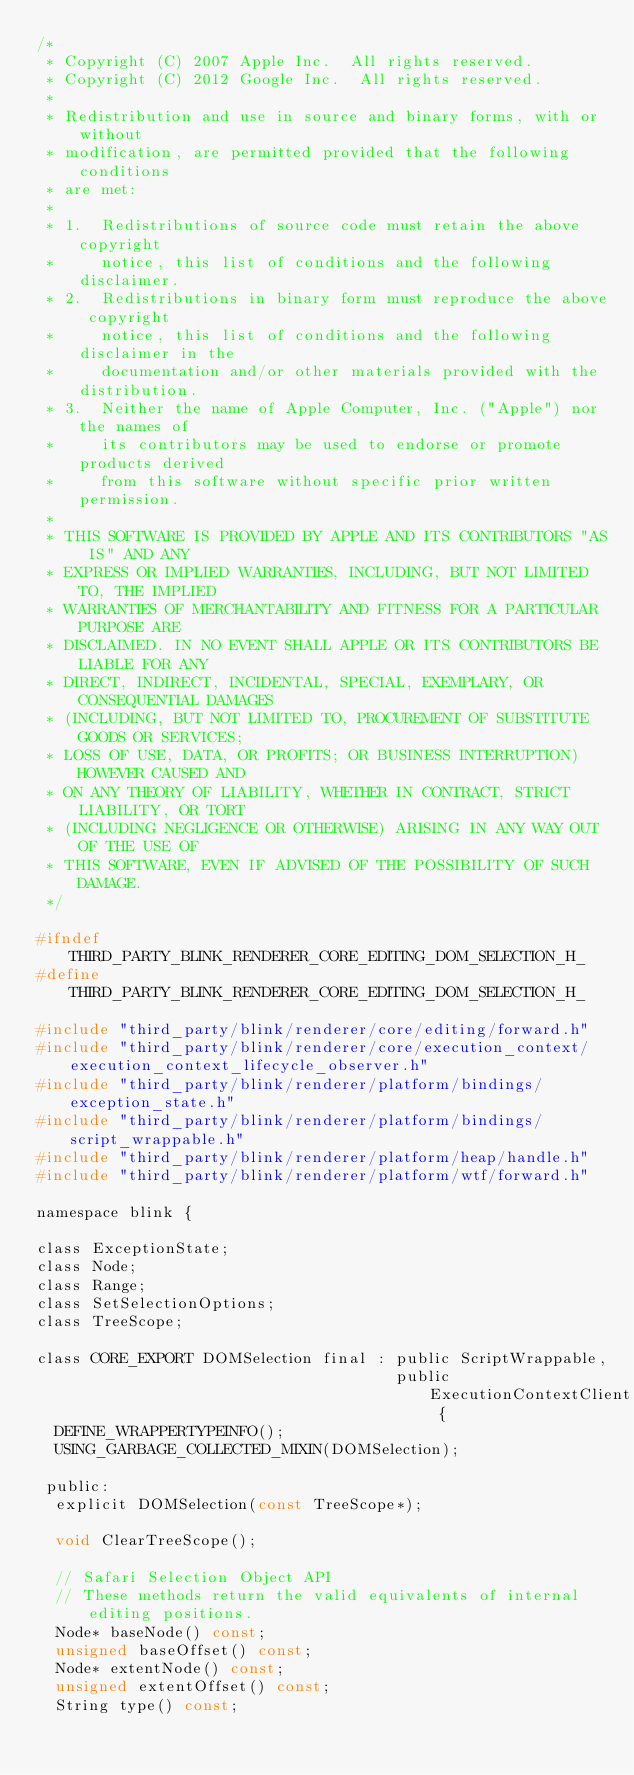Convert code to text. <code><loc_0><loc_0><loc_500><loc_500><_C_>/*
 * Copyright (C) 2007 Apple Inc.  All rights reserved.
 * Copyright (C) 2012 Google Inc.  All rights reserved.
 *
 * Redistribution and use in source and binary forms, with or without
 * modification, are permitted provided that the following conditions
 * are met:
 *
 * 1.  Redistributions of source code must retain the above copyright
 *     notice, this list of conditions and the following disclaimer.
 * 2.  Redistributions in binary form must reproduce the above copyright
 *     notice, this list of conditions and the following disclaimer in the
 *     documentation and/or other materials provided with the distribution.
 * 3.  Neither the name of Apple Computer, Inc. ("Apple") nor the names of
 *     its contributors may be used to endorse or promote products derived
 *     from this software without specific prior written permission.
 *
 * THIS SOFTWARE IS PROVIDED BY APPLE AND ITS CONTRIBUTORS "AS IS" AND ANY
 * EXPRESS OR IMPLIED WARRANTIES, INCLUDING, BUT NOT LIMITED TO, THE IMPLIED
 * WARRANTIES OF MERCHANTABILITY AND FITNESS FOR A PARTICULAR PURPOSE ARE
 * DISCLAIMED. IN NO EVENT SHALL APPLE OR ITS CONTRIBUTORS BE LIABLE FOR ANY
 * DIRECT, INDIRECT, INCIDENTAL, SPECIAL, EXEMPLARY, OR CONSEQUENTIAL DAMAGES
 * (INCLUDING, BUT NOT LIMITED TO, PROCUREMENT OF SUBSTITUTE GOODS OR SERVICES;
 * LOSS OF USE, DATA, OR PROFITS; OR BUSINESS INTERRUPTION) HOWEVER CAUSED AND
 * ON ANY THEORY OF LIABILITY, WHETHER IN CONTRACT, STRICT LIABILITY, OR TORT
 * (INCLUDING NEGLIGENCE OR OTHERWISE) ARISING IN ANY WAY OUT OF THE USE OF
 * THIS SOFTWARE, EVEN IF ADVISED OF THE POSSIBILITY OF SUCH DAMAGE.
 */

#ifndef THIRD_PARTY_BLINK_RENDERER_CORE_EDITING_DOM_SELECTION_H_
#define THIRD_PARTY_BLINK_RENDERER_CORE_EDITING_DOM_SELECTION_H_

#include "third_party/blink/renderer/core/editing/forward.h"
#include "third_party/blink/renderer/core/execution_context/execution_context_lifecycle_observer.h"
#include "third_party/blink/renderer/platform/bindings/exception_state.h"
#include "third_party/blink/renderer/platform/bindings/script_wrappable.h"
#include "third_party/blink/renderer/platform/heap/handle.h"
#include "third_party/blink/renderer/platform/wtf/forward.h"

namespace blink {

class ExceptionState;
class Node;
class Range;
class SetSelectionOptions;
class TreeScope;

class CORE_EXPORT DOMSelection final : public ScriptWrappable,
                                       public ExecutionContextClient {
  DEFINE_WRAPPERTYPEINFO();
  USING_GARBAGE_COLLECTED_MIXIN(DOMSelection);

 public:
  explicit DOMSelection(const TreeScope*);

  void ClearTreeScope();

  // Safari Selection Object API
  // These methods return the valid equivalents of internal editing positions.
  Node* baseNode() const;
  unsigned baseOffset() const;
  Node* extentNode() const;
  unsigned extentOffset() const;
  String type() const;</code> 